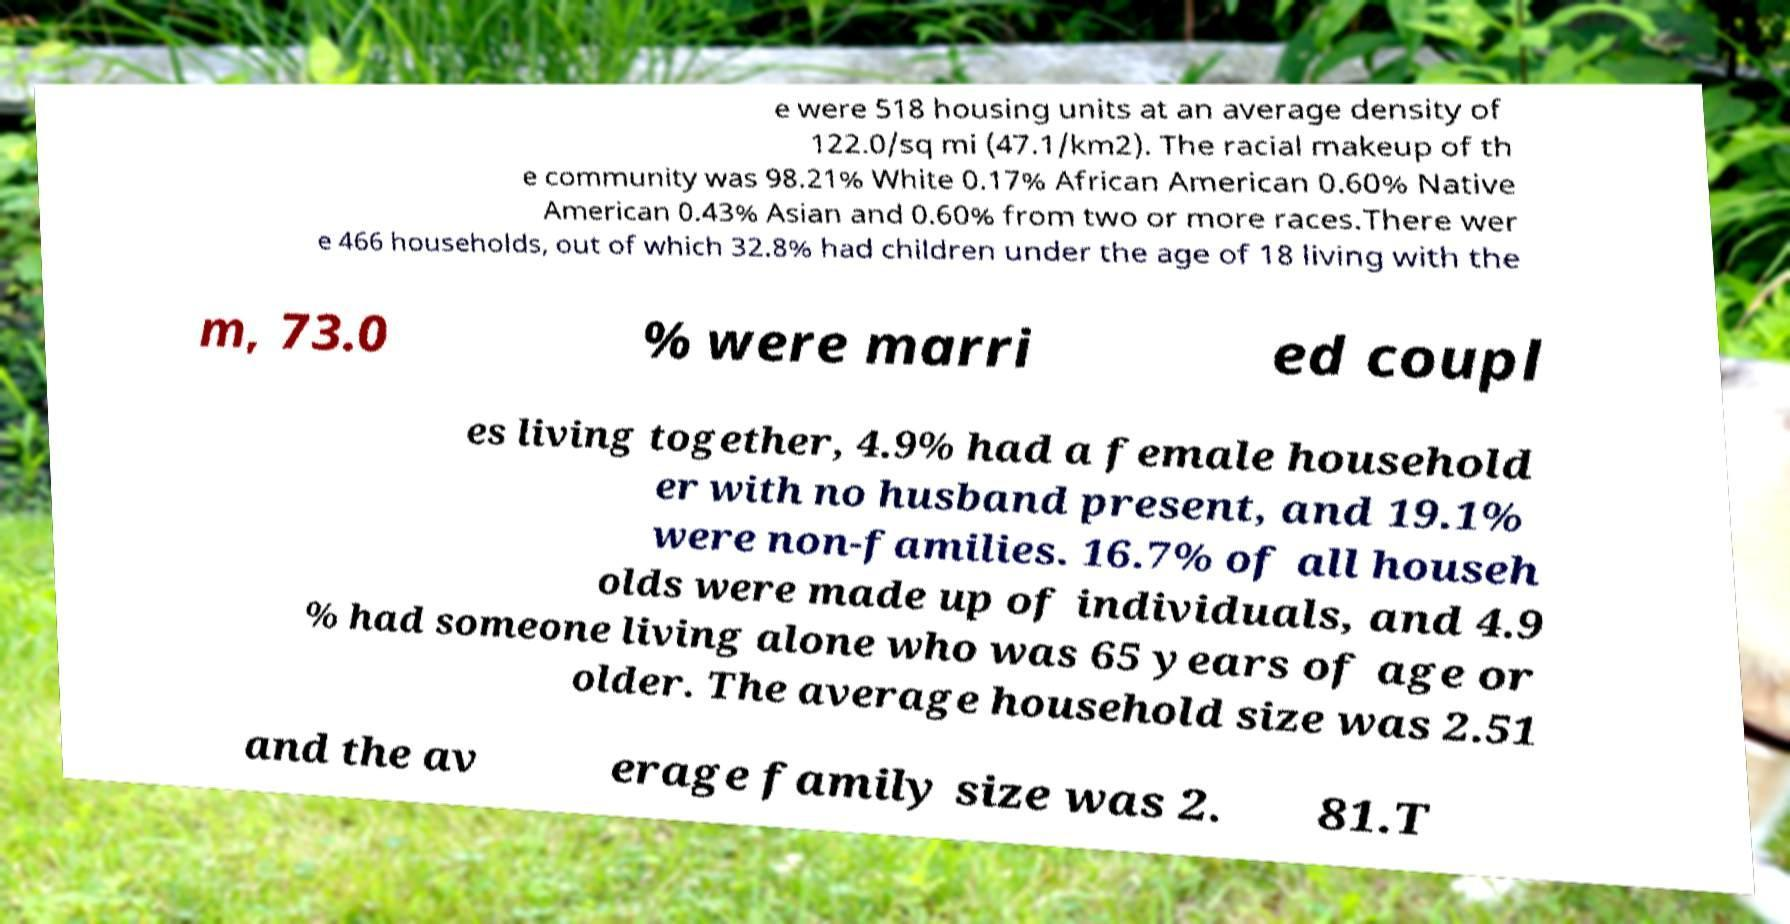There's text embedded in this image that I need extracted. Can you transcribe it verbatim? e were 518 housing units at an average density of 122.0/sq mi (47.1/km2). The racial makeup of th e community was 98.21% White 0.17% African American 0.60% Native American 0.43% Asian and 0.60% from two or more races.There wer e 466 households, out of which 32.8% had children under the age of 18 living with the m, 73.0 % were marri ed coupl es living together, 4.9% had a female household er with no husband present, and 19.1% were non-families. 16.7% of all househ olds were made up of individuals, and 4.9 % had someone living alone who was 65 years of age or older. The average household size was 2.51 and the av erage family size was 2. 81.T 